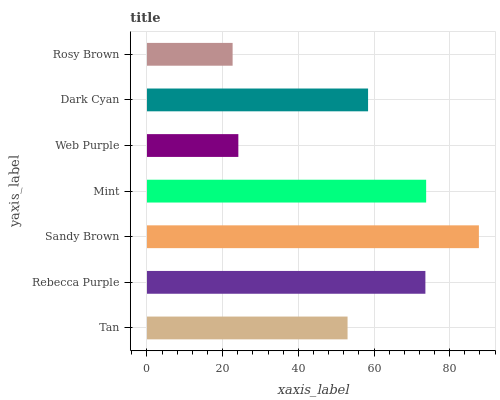Is Rosy Brown the minimum?
Answer yes or no. Yes. Is Sandy Brown the maximum?
Answer yes or no. Yes. Is Rebecca Purple the minimum?
Answer yes or no. No. Is Rebecca Purple the maximum?
Answer yes or no. No. Is Rebecca Purple greater than Tan?
Answer yes or no. Yes. Is Tan less than Rebecca Purple?
Answer yes or no. Yes. Is Tan greater than Rebecca Purple?
Answer yes or no. No. Is Rebecca Purple less than Tan?
Answer yes or no. No. Is Dark Cyan the high median?
Answer yes or no. Yes. Is Dark Cyan the low median?
Answer yes or no. Yes. Is Rebecca Purple the high median?
Answer yes or no. No. Is Rebecca Purple the low median?
Answer yes or no. No. 